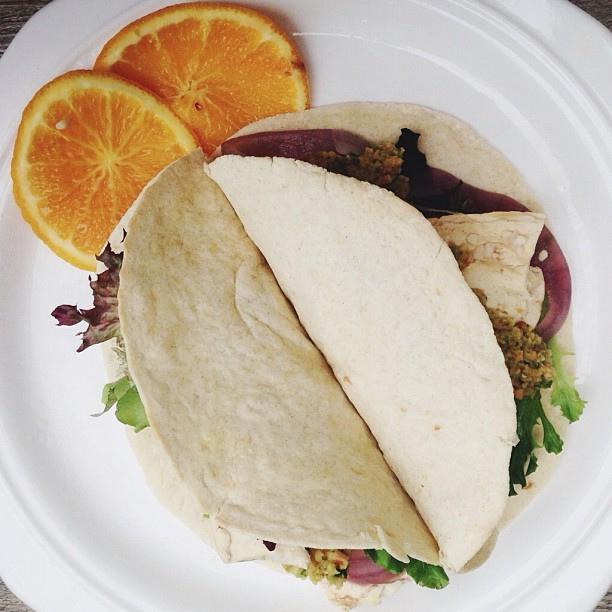Is this fruit lemon?
Give a very brief answer. No. Has any food been taken?
Quick response, please. No. What fruit is on the plate?
Give a very brief answer. Orange. What color is the plate?
Keep it brief. White. 